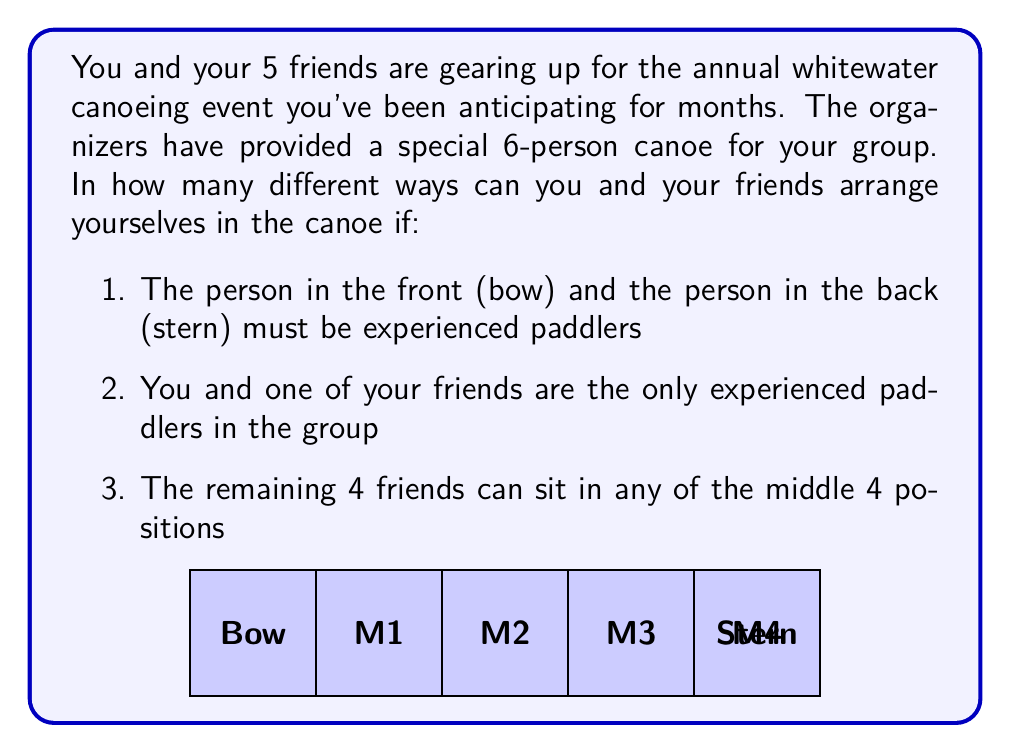Could you help me with this problem? Let's approach this step-by-step:

1) First, let's consider the bow and stern positions. You and your experienced friend must occupy these positions. This can be done in $2!$ ways.

2) Now, for the middle 4 positions (M1, M2, M3, M4), we need to arrange the remaining 4 friends. This is a straightforward permutation of 4 people into 4 positions, which can be done in $4!$ ways.

3) According to the multiplication principle, we multiply these two numbers to get the total number of possible arrangements.

   Total arrangements = (Arrangements of experienced paddlers) × (Arrangements of other friends)
   $$ \text{Total arrangements} = 2! \times 4! $$

4) Let's calculate:
   $$ 2! \times 4! = 2 \times 24 = 48 $$

Therefore, there are 48 different ways to arrange yourselves in the canoe.
Answer: 48 